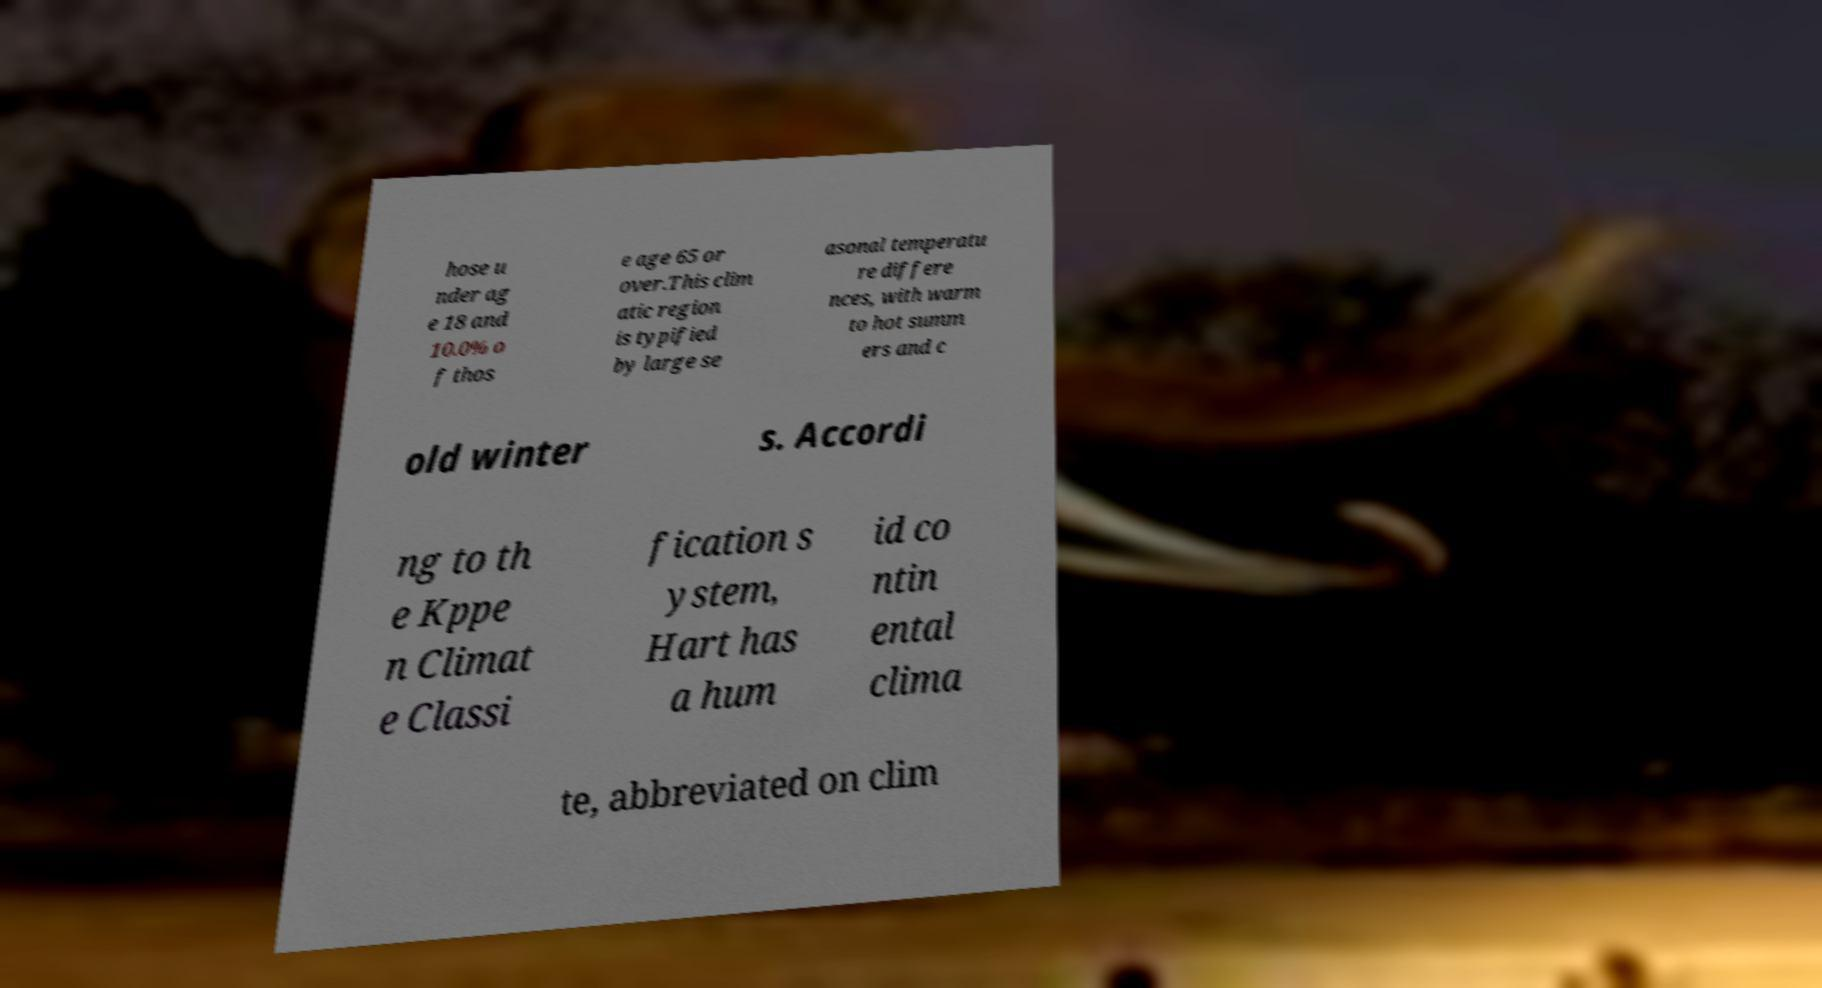Could you assist in decoding the text presented in this image and type it out clearly? hose u nder ag e 18 and 10.0% o f thos e age 65 or over.This clim atic region is typified by large se asonal temperatu re differe nces, with warm to hot summ ers and c old winter s. Accordi ng to th e Kppe n Climat e Classi fication s ystem, Hart has a hum id co ntin ental clima te, abbreviated on clim 